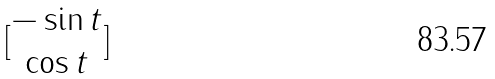Convert formula to latex. <formula><loc_0><loc_0><loc_500><loc_500>[ \begin{matrix} - \sin t \\ \cos t \end{matrix} ]</formula> 